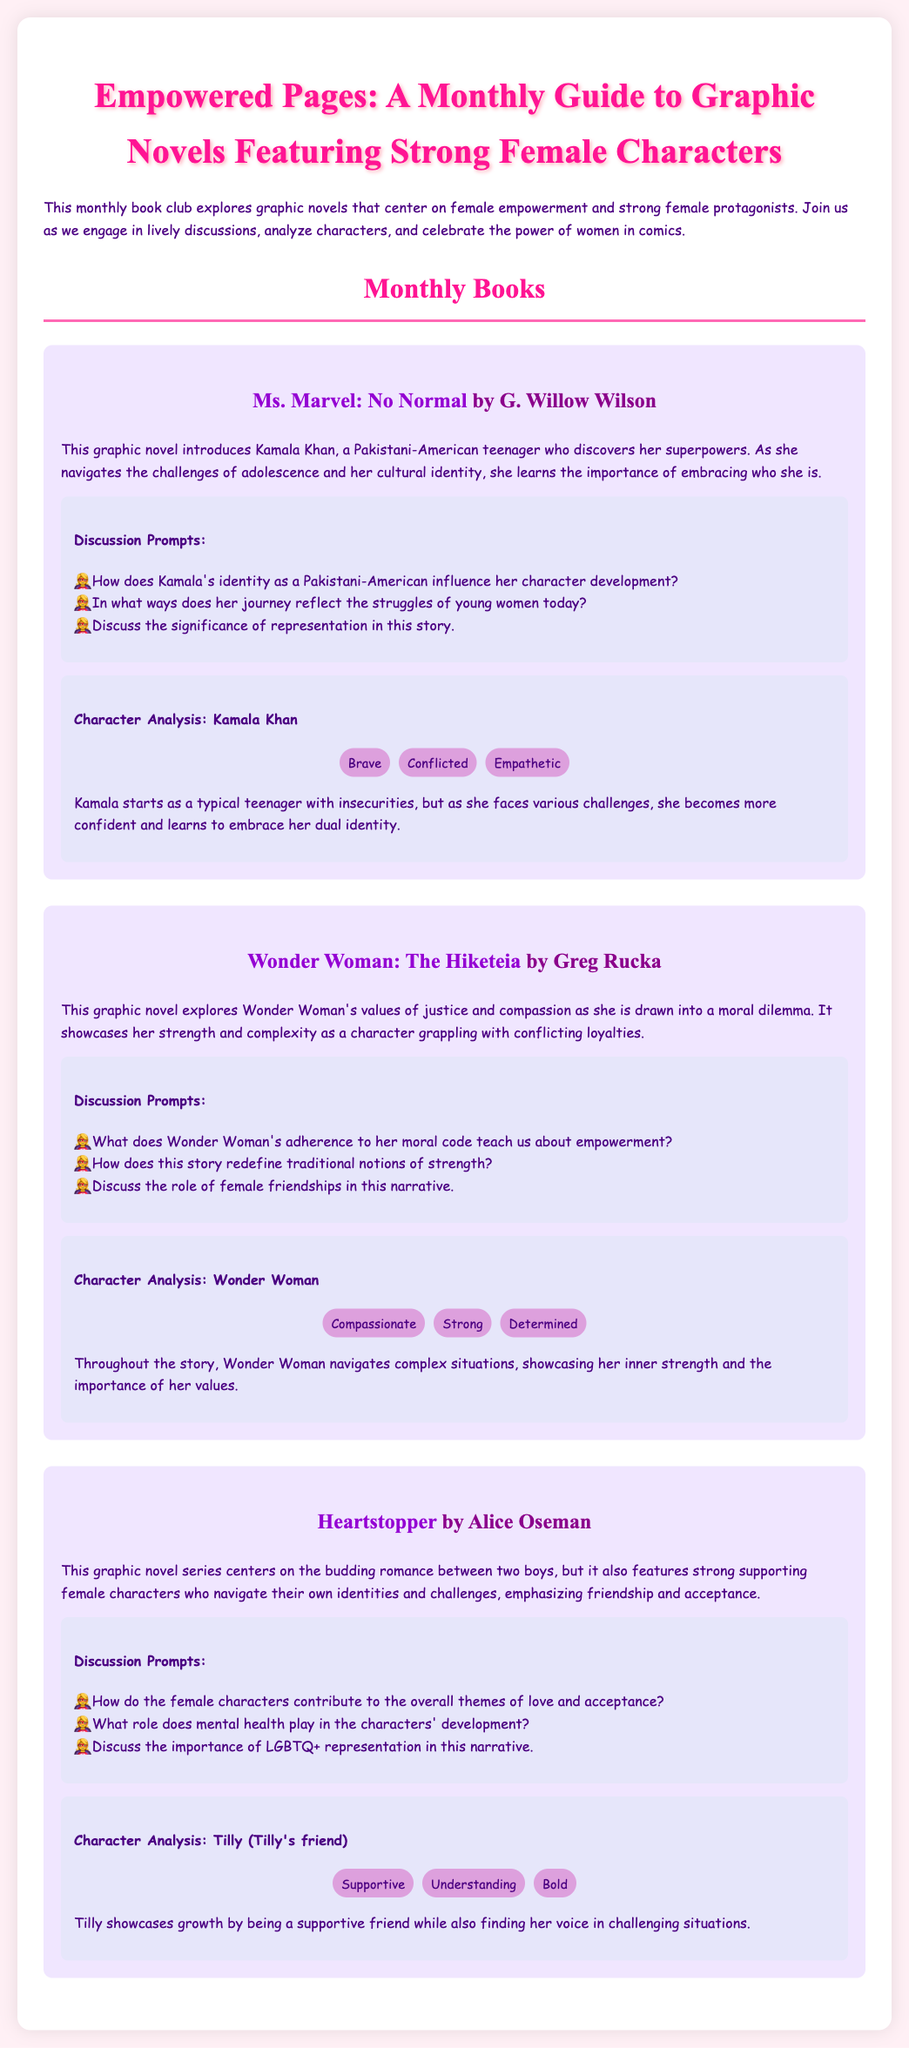What is the title of this monthly book club guide? The title of the guide is stated at the top of the document.
Answer: Empowered Pages: A Monthly Guide to Graphic Novels Featuring Strong Female Characters Who is the author of "Ms. Marvel: No Normal"? The author of "Ms. Marvel: No Normal" is mentioned in the book section of the document.
Answer: G. Willow Wilson What is one of Kamala Khan's traits? The traits of Kamala Khan are listed in her character analysis section.
Answer: Brave How many discussion prompts are provided for "Wonder Woman: The Hiketeia"? The number of discussion prompts is indicated in the section for "Wonder Woman: The Hiketeia."
Answer: Three What theme is emphasized in "Heartstopper"? The theme discussed in relation to "Heartstopper" is mentioned in the summary of the graphic novel.
Answer: Friendship and acceptance What is the main focus of the book club? The document states the book club's main focus in the introductory paragraph.
Answer: Female empowerment Who are the strong female characters being analyzed? The document lists characters that are analyzed, including Kamala Khan and Wonder Woman.
Answer: Kamala Khan, Wonder Woman, Tilly What color is the background for the character analysis sections? The color for the character analysis sections is mentioned in the document.
Answer: #E6E6FA 